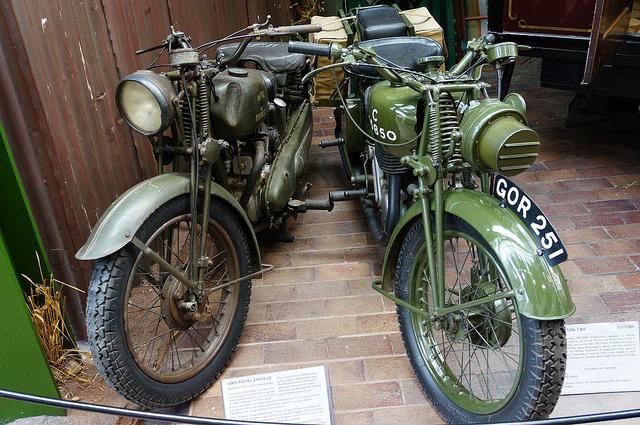Are these bikes for everyday riding?
Short answer required. No. What color is the bike on the right?
Write a very short answer. Green. Would one ride this bike on this surface?
Give a very brief answer. No. What is the number on the right cycle?
Be succinct. 251. 